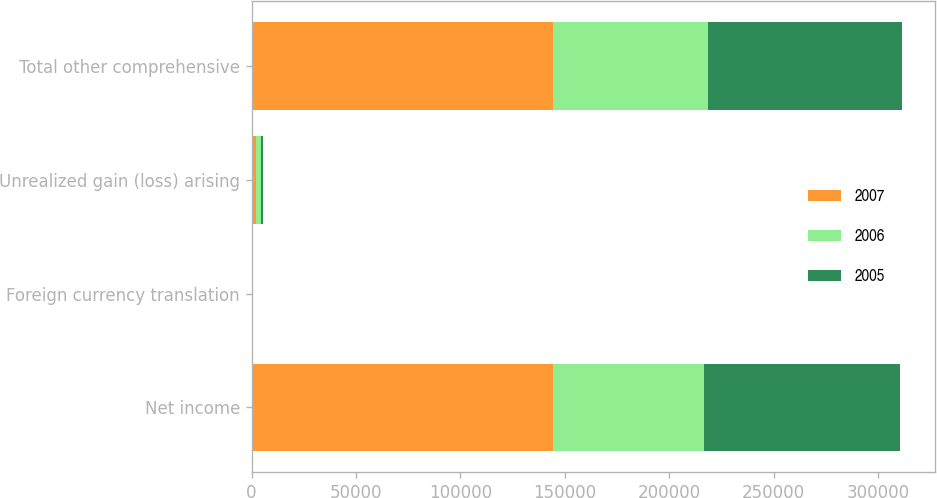Convert chart. <chart><loc_0><loc_0><loc_500><loc_500><stacked_bar_chart><ecel><fcel>Net income<fcel>Foreign currency translation<fcel>Unrealized gain (loss) arising<fcel>Total other comprehensive<nl><fcel>2007<fcel>144537<fcel>12<fcel>2258<fcel>144362<nl><fcel>2006<fcel>72044<fcel>22<fcel>2160<fcel>74226<nl><fcel>2005<fcel>94134<fcel>49<fcel>1134<fcel>93049<nl></chart> 